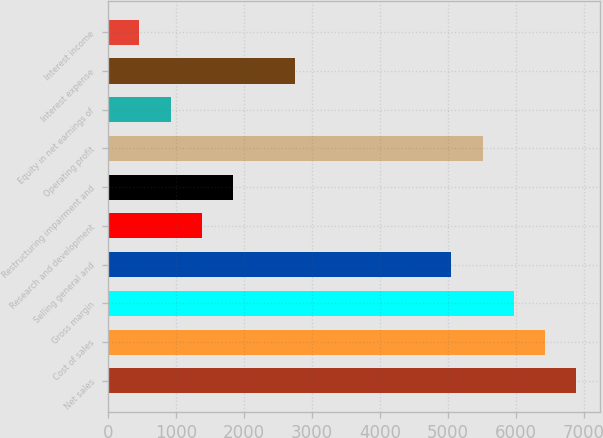Convert chart to OTSL. <chart><loc_0><loc_0><loc_500><loc_500><bar_chart><fcel>Net sales<fcel>Cost of sales<fcel>Gross margin<fcel>Selling general and<fcel>Research and development<fcel>Restructuring impairment and<fcel>Operating profit<fcel>Equity in net earnings of<fcel>Interest expense<fcel>Interest income<nl><fcel>6887.5<fcel>6428.4<fcel>5969.3<fcel>5051.1<fcel>1378.3<fcel>1837.4<fcel>5510.2<fcel>919.2<fcel>2755.6<fcel>460.1<nl></chart> 